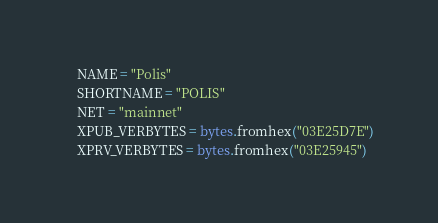Convert code to text. <code><loc_0><loc_0><loc_500><loc_500><_Python_>    NAME = "Polis"
    SHORTNAME = "POLIS"
    NET = "mainnet"
    XPUB_VERBYTES = bytes.fromhex("03E25D7E")
    XPRV_VERBYTES = bytes.fromhex("03E25945")</code> 